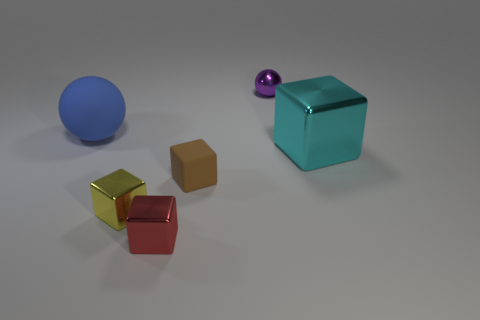Add 4 big blue things. How many objects exist? 10 Subtract all blocks. How many objects are left? 2 Add 3 cyan spheres. How many cyan spheres exist? 3 Subtract 1 brown blocks. How many objects are left? 5 Subtract all red metal things. Subtract all metal balls. How many objects are left? 4 Add 6 large blue balls. How many large blue balls are left? 7 